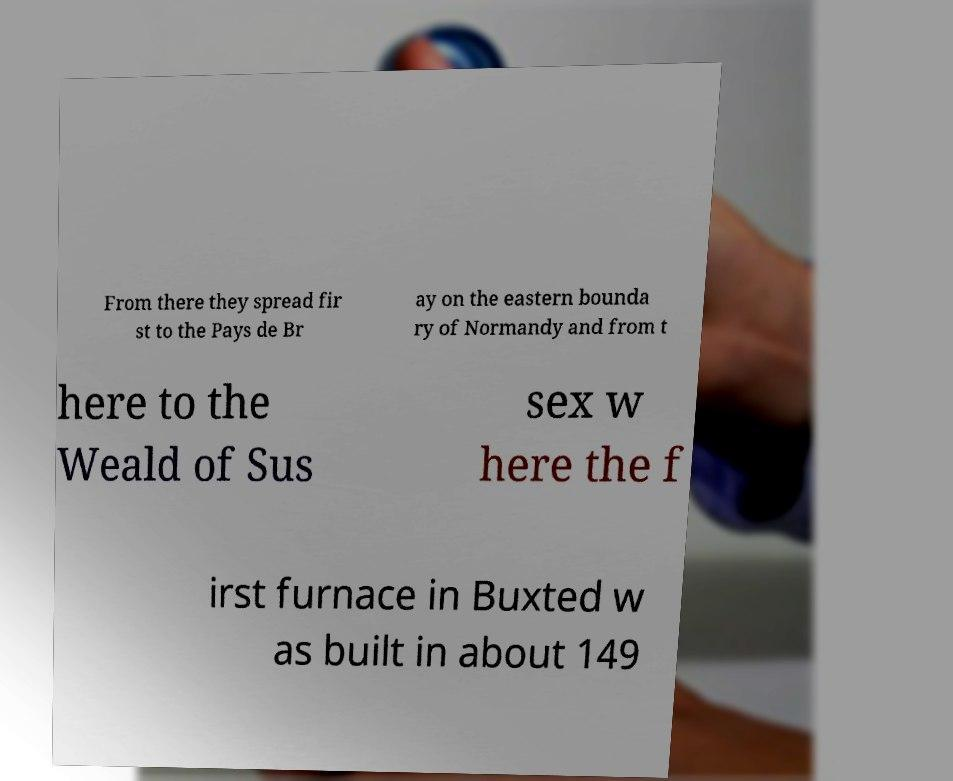Can you read and provide the text displayed in the image?This photo seems to have some interesting text. Can you extract and type it out for me? From there they spread fir st to the Pays de Br ay on the eastern bounda ry of Normandy and from t here to the Weald of Sus sex w here the f irst furnace in Buxted w as built in about 149 